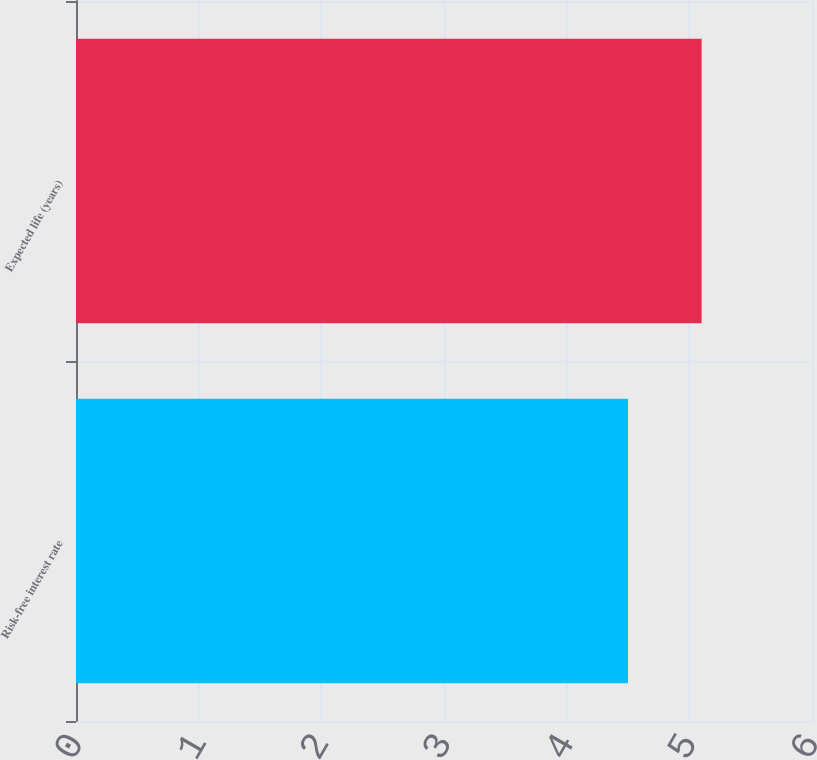Convert chart to OTSL. <chart><loc_0><loc_0><loc_500><loc_500><bar_chart><fcel>Risk-free interest rate<fcel>Expected life (years)<nl><fcel>4.5<fcel>5.1<nl></chart> 